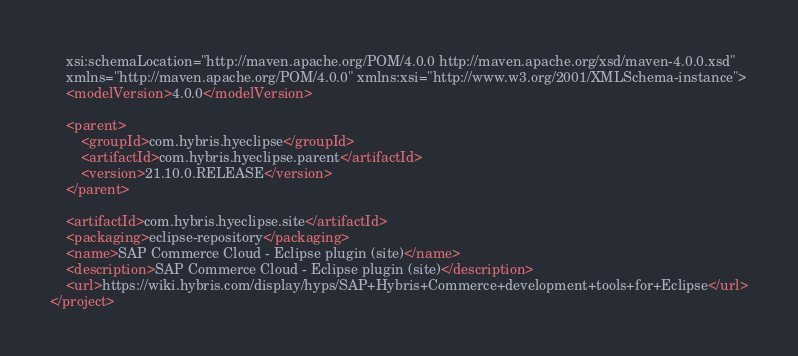Convert code to text. <code><loc_0><loc_0><loc_500><loc_500><_XML_>	xsi:schemaLocation="http://maven.apache.org/POM/4.0.0 http://maven.apache.org/xsd/maven-4.0.0.xsd"
	xmlns="http://maven.apache.org/POM/4.0.0" xmlns:xsi="http://www.w3.org/2001/XMLSchema-instance">
	<modelVersion>4.0.0</modelVersion>

	<parent>
		<groupId>com.hybris.hyeclipse</groupId>
		<artifactId>com.hybris.hyeclipse.parent</artifactId>
		<version>21.10.0.RELEASE</version>
	</parent>

	<artifactId>com.hybris.hyeclipse.site</artifactId>
	<packaging>eclipse-repository</packaging>
	<name>SAP Commerce Cloud - Eclipse plugin (site)</name>
	<description>SAP Commerce Cloud - Eclipse plugin (site)</description>
	<url>https://wiki.hybris.com/display/hyps/SAP+Hybris+Commerce+development+tools+for+Eclipse</url>
</project>
</code> 